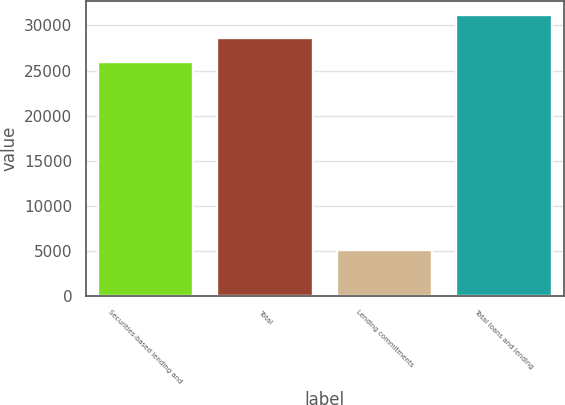Convert chart to OTSL. <chart><loc_0><loc_0><loc_500><loc_500><bar_chart><fcel>Securities-based lending and<fcel>Total<fcel>Lending commitments<fcel>Total loans and lending<nl><fcel>25975<fcel>28572.5<fcel>5143<fcel>31170<nl></chart> 